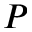Convert formula to latex. <formula><loc_0><loc_0><loc_500><loc_500>P</formula> 